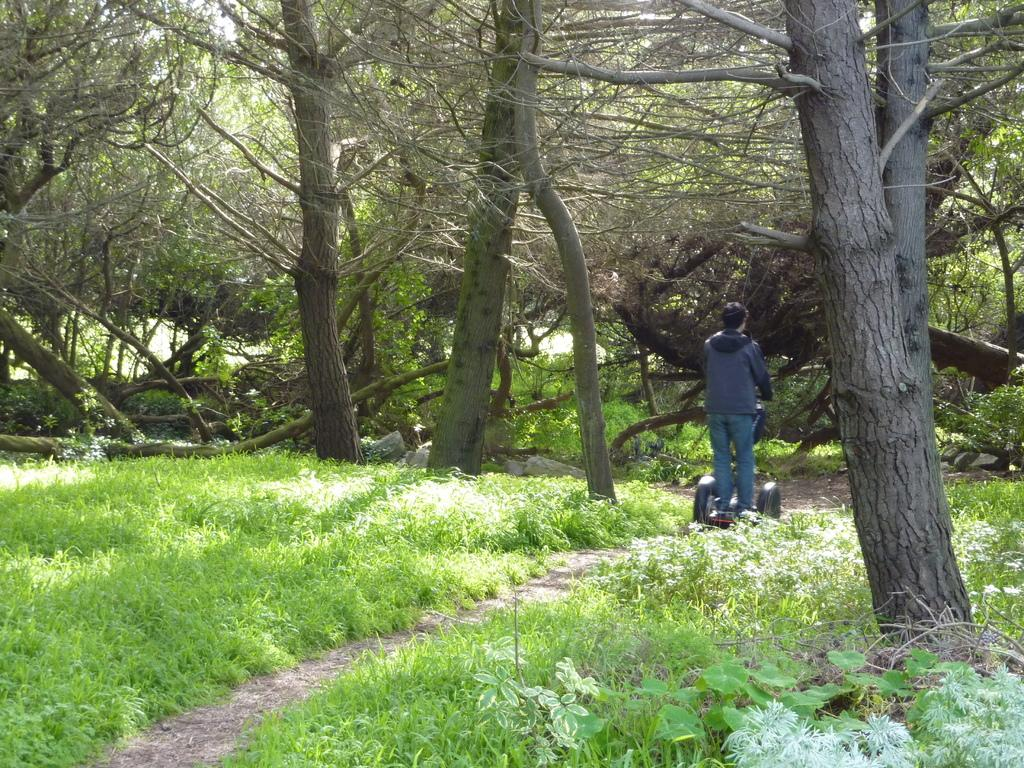What is the person in the image doing? The person is on a vehicle in the image. What can be seen in the background of the image? There are trees visible in the image. What type of vegetation is present in the image? There is green grass in the image. Can you tell me how many balls the tiger is holding in the image? There is no tiger or ball present in the image. 